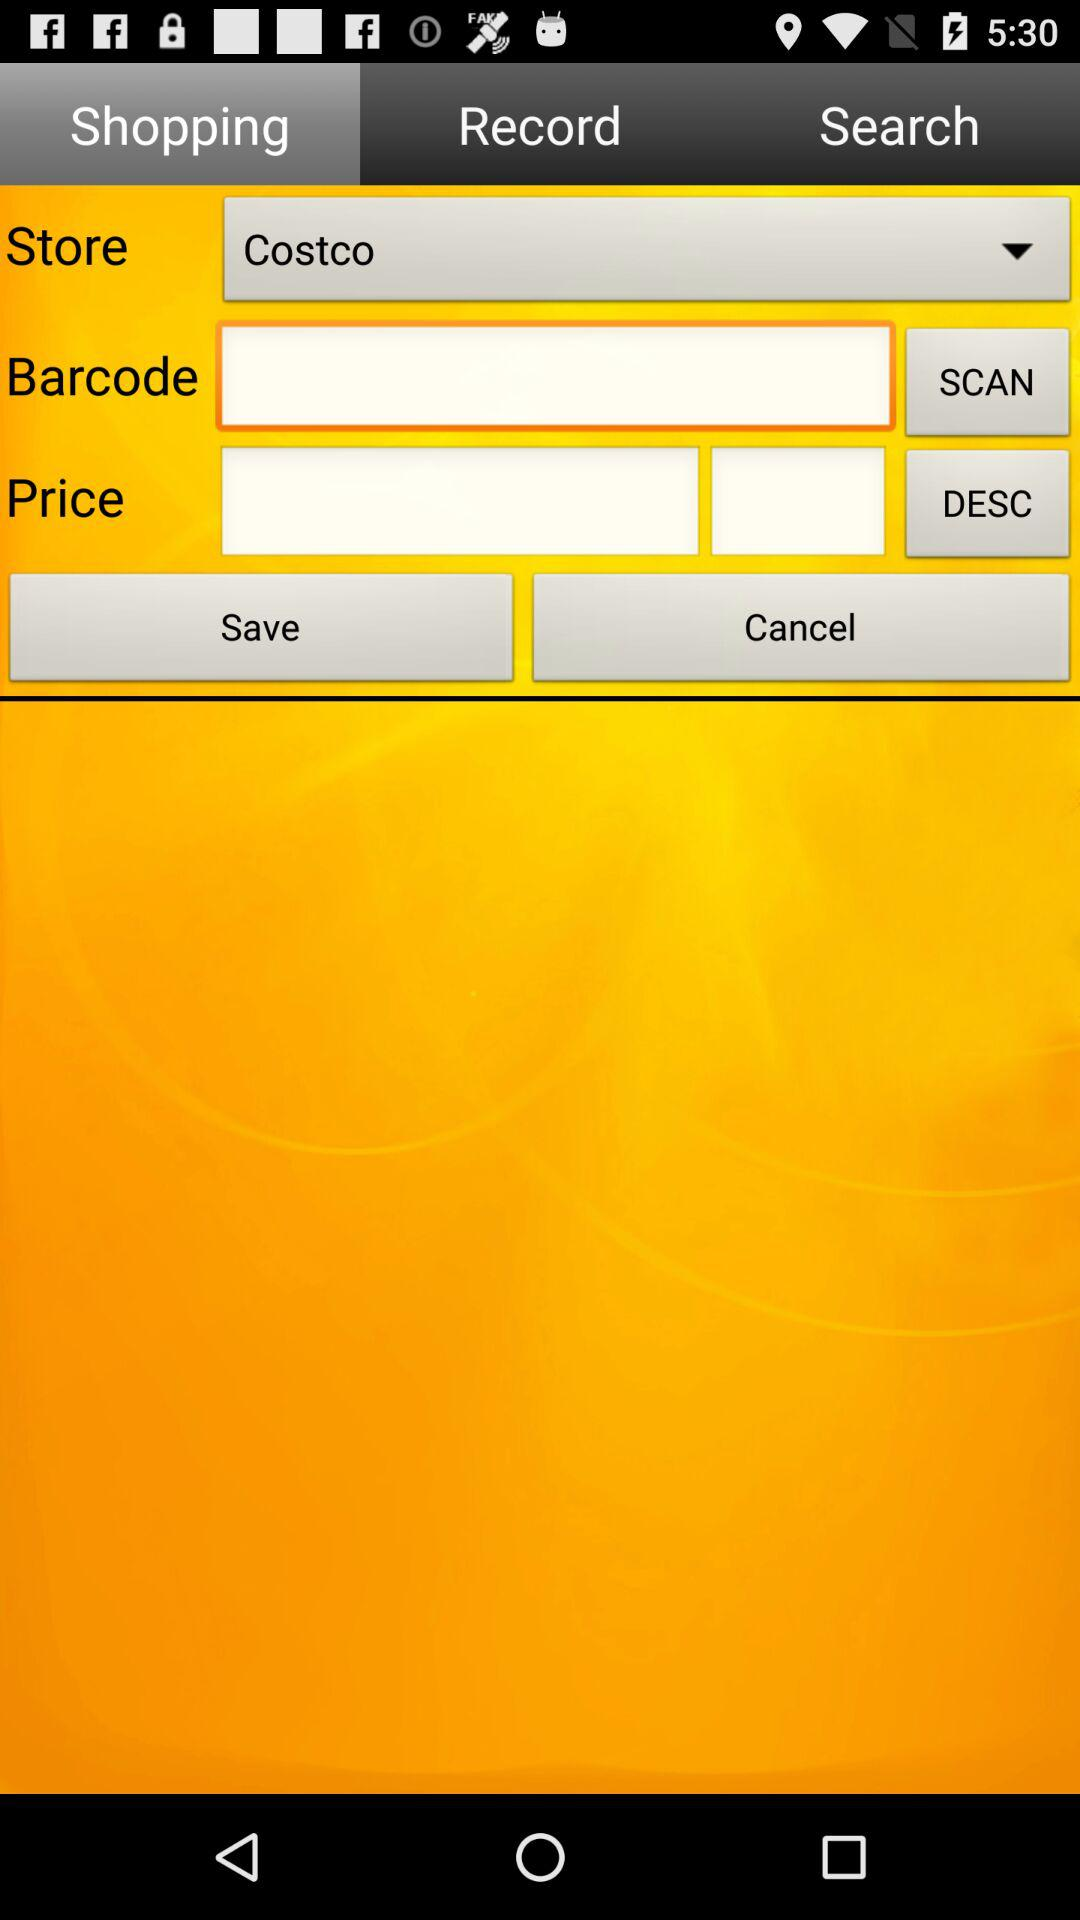Which tab is selected? The selected tab is "Shopping". 